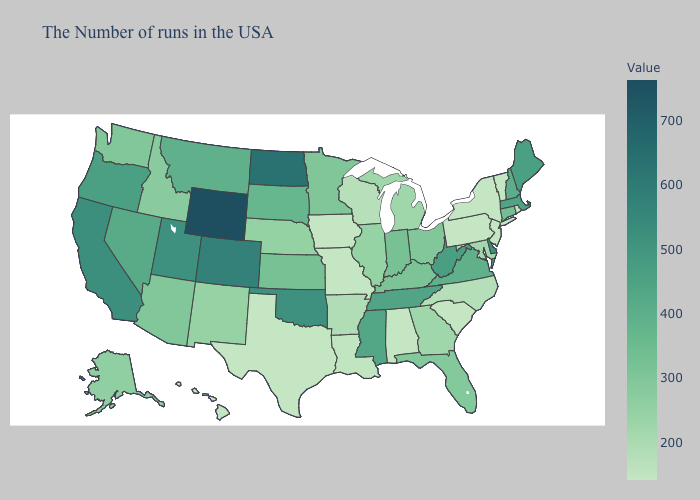Is the legend a continuous bar?
Concise answer only. Yes. Does Mississippi have a higher value than Arkansas?
Answer briefly. Yes. Which states have the highest value in the USA?
Concise answer only. Wyoming. Among the states that border Arkansas , which have the lowest value?
Write a very short answer. Missouri, Texas. Is the legend a continuous bar?
Answer briefly. Yes. 